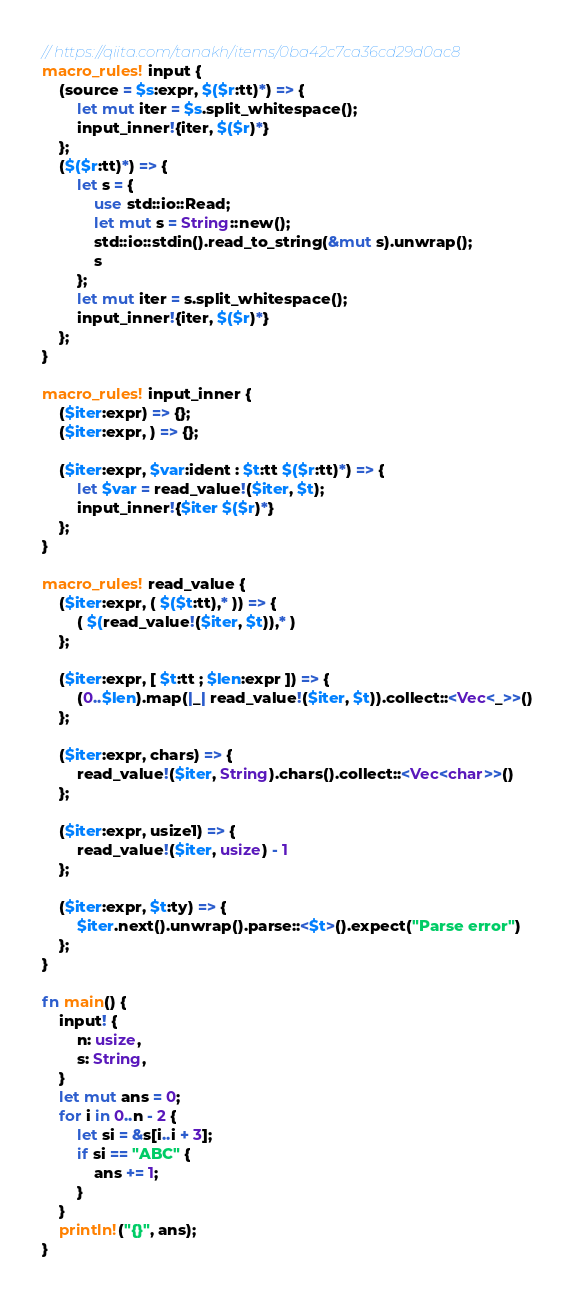Convert code to text. <code><loc_0><loc_0><loc_500><loc_500><_Rust_>// https://qiita.com/tanakh/items/0ba42c7ca36cd29d0ac8
macro_rules! input {
    (source = $s:expr, $($r:tt)*) => {
        let mut iter = $s.split_whitespace();
        input_inner!{iter, $($r)*}
    };
    ($($r:tt)*) => {
        let s = {
            use std::io::Read;
            let mut s = String::new();
            std::io::stdin().read_to_string(&mut s).unwrap();
            s
        };
        let mut iter = s.split_whitespace();
        input_inner!{iter, $($r)*}
    };
}

macro_rules! input_inner {
    ($iter:expr) => {};
    ($iter:expr, ) => {};

    ($iter:expr, $var:ident : $t:tt $($r:tt)*) => {
        let $var = read_value!($iter, $t);
        input_inner!{$iter $($r)*}
    };
}

macro_rules! read_value {
    ($iter:expr, ( $($t:tt),* )) => {
        ( $(read_value!($iter, $t)),* )
    };

    ($iter:expr, [ $t:tt ; $len:expr ]) => {
        (0..$len).map(|_| read_value!($iter, $t)).collect::<Vec<_>>()
    };

    ($iter:expr, chars) => {
        read_value!($iter, String).chars().collect::<Vec<char>>()
    };

    ($iter:expr, usize1) => {
        read_value!($iter, usize) - 1
    };

    ($iter:expr, $t:ty) => {
        $iter.next().unwrap().parse::<$t>().expect("Parse error")
    };
}

fn main() {
    input! {
        n: usize,
        s: String,
    }
    let mut ans = 0;
    for i in 0..n - 2 {
        let si = &s[i..i + 3];
        if si == "ABC" {
            ans += 1;
        }
    }
    println!("{}", ans);
}
</code> 